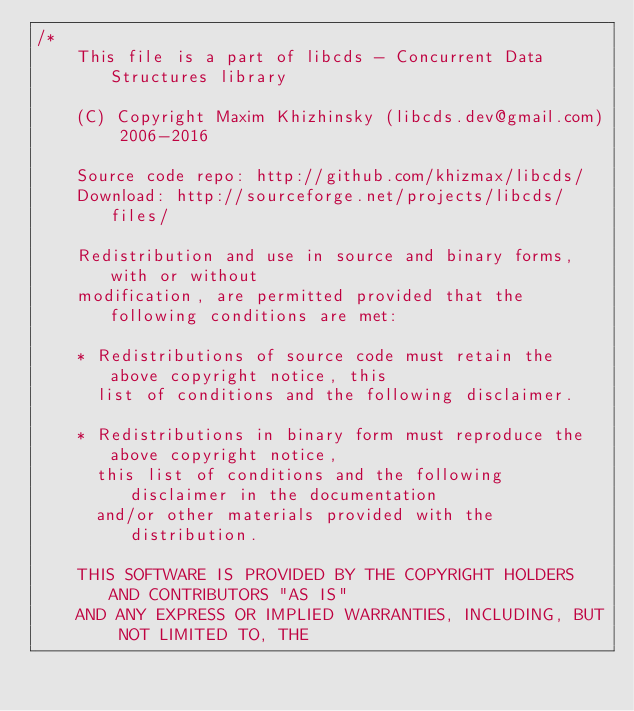<code> <loc_0><loc_0><loc_500><loc_500><_C++_>/*
    This file is a part of libcds - Concurrent Data Structures library

    (C) Copyright Maxim Khizhinsky (libcds.dev@gmail.com) 2006-2016

    Source code repo: http://github.com/khizmax/libcds/
    Download: http://sourceforge.net/projects/libcds/files/

    Redistribution and use in source and binary forms, with or without
    modification, are permitted provided that the following conditions are met:

    * Redistributions of source code must retain the above copyright notice, this
      list of conditions and the following disclaimer.

    * Redistributions in binary form must reproduce the above copyright notice,
      this list of conditions and the following disclaimer in the documentation
      and/or other materials provided with the distribution.

    THIS SOFTWARE IS PROVIDED BY THE COPYRIGHT HOLDERS AND CONTRIBUTORS "AS IS"
    AND ANY EXPRESS OR IMPLIED WARRANTIES, INCLUDING, BUT NOT LIMITED TO, THE</code> 